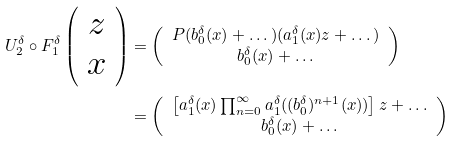<formula> <loc_0><loc_0><loc_500><loc_500>U _ { 2 } ^ { \delta } \circ F _ { 1 } ^ { \delta } \left ( \begin{array} { c } z \\ x \end{array} \right ) & = \left ( \begin{array} { c } P ( b _ { 0 } ^ { \delta } ( x ) + \dots ) ( a _ { 1 } ^ { \delta } ( x ) z + \dots ) \\ b _ { 0 } ^ { \delta } ( x ) + \dots \end{array} \right ) \\ & = \left ( \begin{array} { c } \left [ a _ { 1 } ^ { \delta } ( x ) \prod _ { n = 0 } ^ { \infty } a _ { 1 } ^ { \delta } ( ( b _ { 0 } ^ { \delta } ) ^ { n + 1 } ( x ) ) \right ] z + \dots \\ b _ { 0 } ^ { \delta } ( x ) + \dots \end{array} \right )</formula> 